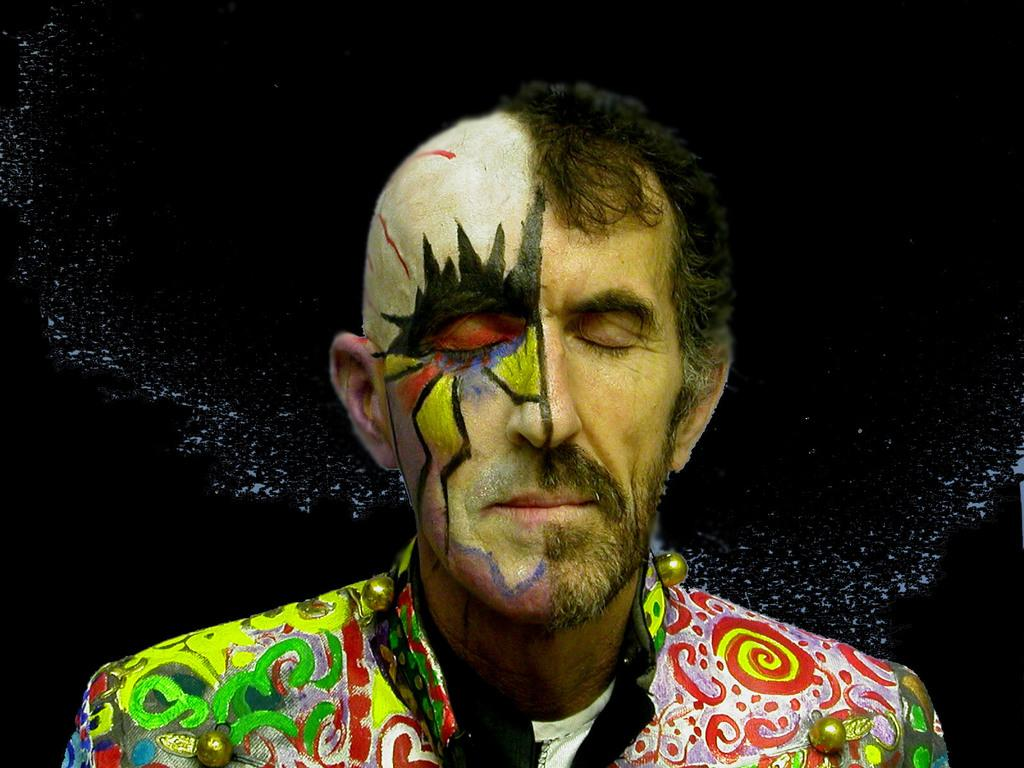What is the main subject of the image? The main subject of the image is a person's face. What is unique about the person's face in the image? The person's face has a painting on it. What type of flag is being waved by the person in the image? There is no flag present in the image; it only features a person's face with a painting on it. 